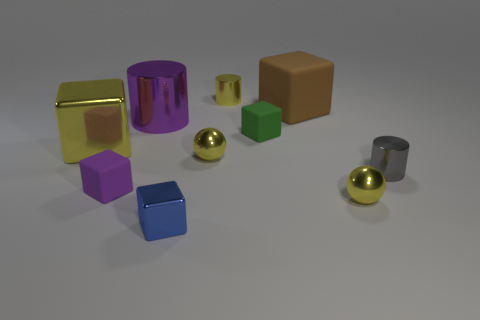There is a rubber object that is the same color as the large cylinder; what is its size?
Provide a succinct answer. Small. Are there any purple objects made of the same material as the brown object?
Give a very brief answer. Yes. Do the brown block and the small blue cube have the same material?
Provide a short and direct response. No. There is another shiny cylinder that is the same size as the yellow cylinder; what color is it?
Offer a very short reply. Gray. What number of other things are the same shape as the small purple thing?
Your answer should be compact. 4. There is a brown rubber thing; is it the same size as the metallic cube left of the big purple metal cylinder?
Offer a terse response. Yes. What number of objects are either big brown rubber things or tiny gray cylinders?
Make the answer very short. 2. What number of other objects are the same size as the purple cube?
Your answer should be very brief. 6. Does the large cylinder have the same color as the rubber cube that is in front of the gray object?
Provide a succinct answer. Yes. How many cylinders are either yellow metallic objects or blue objects?
Provide a succinct answer. 1. 